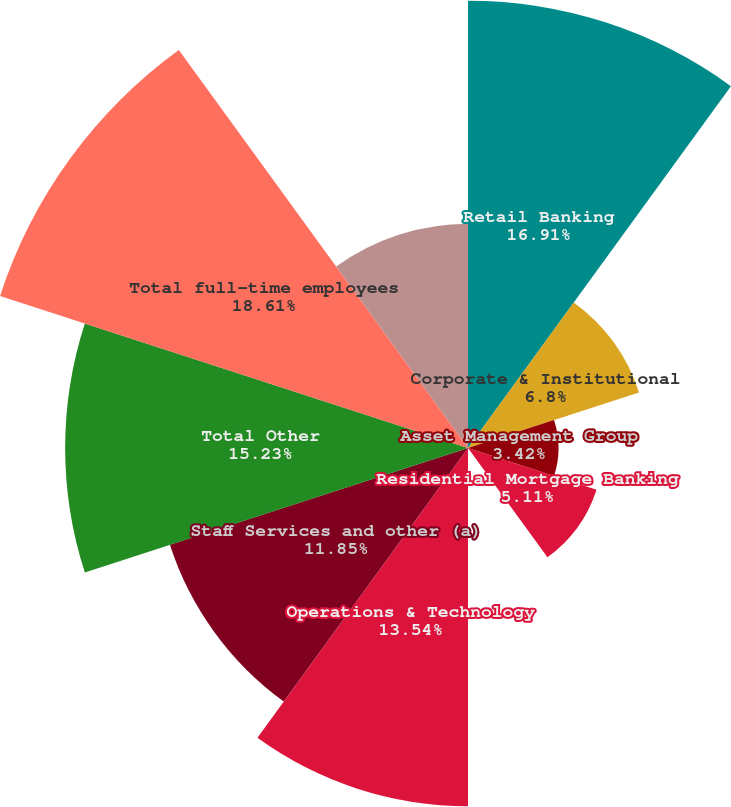Convert chart. <chart><loc_0><loc_0><loc_500><loc_500><pie_chart><fcel>Retail Banking<fcel>Corporate & Institutional<fcel>Asset Management Group<fcel>Residential Mortgage Banking<fcel>Distressed Assets Portfolio<fcel>Operations & Technology<fcel>Staff Services and other (a)<fcel>Total Other<fcel>Total full-time employees<fcel>Retail Banking part-time<nl><fcel>16.91%<fcel>6.8%<fcel>3.42%<fcel>5.11%<fcel>0.05%<fcel>13.54%<fcel>11.85%<fcel>15.23%<fcel>18.6%<fcel>8.48%<nl></chart> 